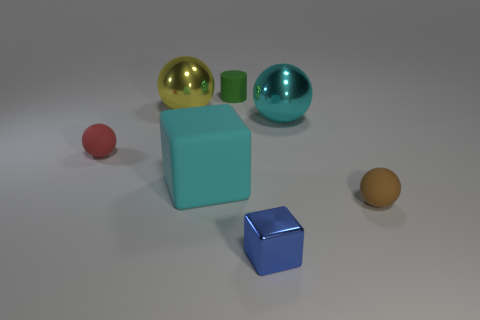The thing that is in front of the small matte ball that is to the right of the small matte sphere that is to the left of the green matte cylinder is made of what material?
Your answer should be compact. Metal. Are there more blue objects that are behind the brown rubber object than large cyan matte blocks behind the matte block?
Your response must be concise. No. What number of balls are made of the same material as the small cylinder?
Provide a succinct answer. 2. Does the large thing that is on the right side of the cyan matte cube have the same shape as the object that is behind the big yellow ball?
Your response must be concise. No. There is a metallic sphere that is to the right of the cylinder; what is its color?
Offer a very short reply. Cyan. Is there another small blue object that has the same shape as the small shiny thing?
Give a very brief answer. No. What is the material of the brown ball?
Your answer should be very brief. Rubber. There is a object that is both in front of the yellow shiny thing and to the left of the large rubber cube; what size is it?
Make the answer very short. Small. What material is the sphere that is the same color as the matte block?
Keep it short and to the point. Metal. What number of cyan spheres are there?
Provide a succinct answer. 1. 